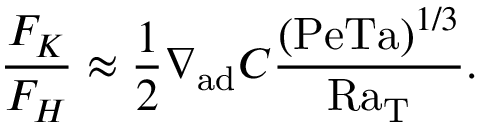Convert formula to latex. <formula><loc_0><loc_0><loc_500><loc_500>{ \frac { F _ { K } } { F _ { H } } } \approx { \frac { 1 } { 2 } } \nabla _ { a d } C { \frac { ( P e T a ) ^ { 1 / 3 } } { R a _ { T } } } .</formula> 